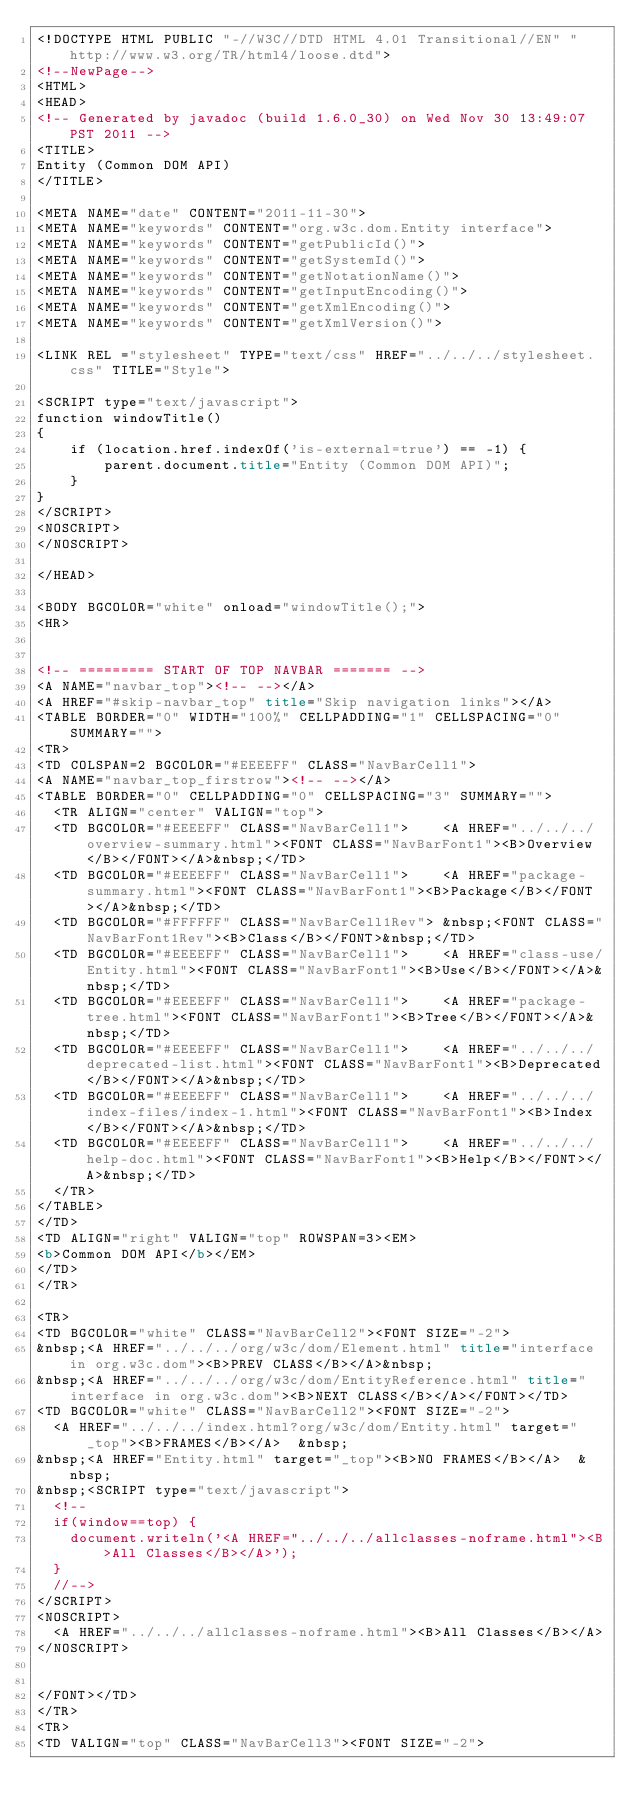Convert code to text. <code><loc_0><loc_0><loc_500><loc_500><_HTML_><!DOCTYPE HTML PUBLIC "-//W3C//DTD HTML 4.01 Transitional//EN" "http://www.w3.org/TR/html4/loose.dtd">
<!--NewPage-->
<HTML>
<HEAD>
<!-- Generated by javadoc (build 1.6.0_30) on Wed Nov 30 13:49:07 PST 2011 -->
<TITLE>
Entity (Common DOM API)
</TITLE>

<META NAME="date" CONTENT="2011-11-30">
<META NAME="keywords" CONTENT="org.w3c.dom.Entity interface">
<META NAME="keywords" CONTENT="getPublicId()">
<META NAME="keywords" CONTENT="getSystemId()">
<META NAME="keywords" CONTENT="getNotationName()">
<META NAME="keywords" CONTENT="getInputEncoding()">
<META NAME="keywords" CONTENT="getXmlEncoding()">
<META NAME="keywords" CONTENT="getXmlVersion()">

<LINK REL ="stylesheet" TYPE="text/css" HREF="../../../stylesheet.css" TITLE="Style">

<SCRIPT type="text/javascript">
function windowTitle()
{
    if (location.href.indexOf('is-external=true') == -1) {
        parent.document.title="Entity (Common DOM API)";
    }
}
</SCRIPT>
<NOSCRIPT>
</NOSCRIPT>

</HEAD>

<BODY BGCOLOR="white" onload="windowTitle();">
<HR>


<!-- ========= START OF TOP NAVBAR ======= -->
<A NAME="navbar_top"><!-- --></A>
<A HREF="#skip-navbar_top" title="Skip navigation links"></A>
<TABLE BORDER="0" WIDTH="100%" CELLPADDING="1" CELLSPACING="0" SUMMARY="">
<TR>
<TD COLSPAN=2 BGCOLOR="#EEEEFF" CLASS="NavBarCell1">
<A NAME="navbar_top_firstrow"><!-- --></A>
<TABLE BORDER="0" CELLPADDING="0" CELLSPACING="3" SUMMARY="">
  <TR ALIGN="center" VALIGN="top">
  <TD BGCOLOR="#EEEEFF" CLASS="NavBarCell1">    <A HREF="../../../overview-summary.html"><FONT CLASS="NavBarFont1"><B>Overview</B></FONT></A>&nbsp;</TD>
  <TD BGCOLOR="#EEEEFF" CLASS="NavBarCell1">    <A HREF="package-summary.html"><FONT CLASS="NavBarFont1"><B>Package</B></FONT></A>&nbsp;</TD>
  <TD BGCOLOR="#FFFFFF" CLASS="NavBarCell1Rev"> &nbsp;<FONT CLASS="NavBarFont1Rev"><B>Class</B></FONT>&nbsp;</TD>
  <TD BGCOLOR="#EEEEFF" CLASS="NavBarCell1">    <A HREF="class-use/Entity.html"><FONT CLASS="NavBarFont1"><B>Use</B></FONT></A>&nbsp;</TD>
  <TD BGCOLOR="#EEEEFF" CLASS="NavBarCell1">    <A HREF="package-tree.html"><FONT CLASS="NavBarFont1"><B>Tree</B></FONT></A>&nbsp;</TD>
  <TD BGCOLOR="#EEEEFF" CLASS="NavBarCell1">    <A HREF="../../../deprecated-list.html"><FONT CLASS="NavBarFont1"><B>Deprecated</B></FONT></A>&nbsp;</TD>
  <TD BGCOLOR="#EEEEFF" CLASS="NavBarCell1">    <A HREF="../../../index-files/index-1.html"><FONT CLASS="NavBarFont1"><B>Index</B></FONT></A>&nbsp;</TD>
  <TD BGCOLOR="#EEEEFF" CLASS="NavBarCell1">    <A HREF="../../../help-doc.html"><FONT CLASS="NavBarFont1"><B>Help</B></FONT></A>&nbsp;</TD>
  </TR>
</TABLE>
</TD>
<TD ALIGN="right" VALIGN="top" ROWSPAN=3><EM>
<b>Common DOM API</b></EM>
</TD>
</TR>

<TR>
<TD BGCOLOR="white" CLASS="NavBarCell2"><FONT SIZE="-2">
&nbsp;<A HREF="../../../org/w3c/dom/Element.html" title="interface in org.w3c.dom"><B>PREV CLASS</B></A>&nbsp;
&nbsp;<A HREF="../../../org/w3c/dom/EntityReference.html" title="interface in org.w3c.dom"><B>NEXT CLASS</B></A></FONT></TD>
<TD BGCOLOR="white" CLASS="NavBarCell2"><FONT SIZE="-2">
  <A HREF="../../../index.html?org/w3c/dom/Entity.html" target="_top"><B>FRAMES</B></A>  &nbsp;
&nbsp;<A HREF="Entity.html" target="_top"><B>NO FRAMES</B></A>  &nbsp;
&nbsp;<SCRIPT type="text/javascript">
  <!--
  if(window==top) {
    document.writeln('<A HREF="../../../allclasses-noframe.html"><B>All Classes</B></A>');
  }
  //-->
</SCRIPT>
<NOSCRIPT>
  <A HREF="../../../allclasses-noframe.html"><B>All Classes</B></A>
</NOSCRIPT>


</FONT></TD>
</TR>
<TR>
<TD VALIGN="top" CLASS="NavBarCell3"><FONT SIZE="-2"></code> 